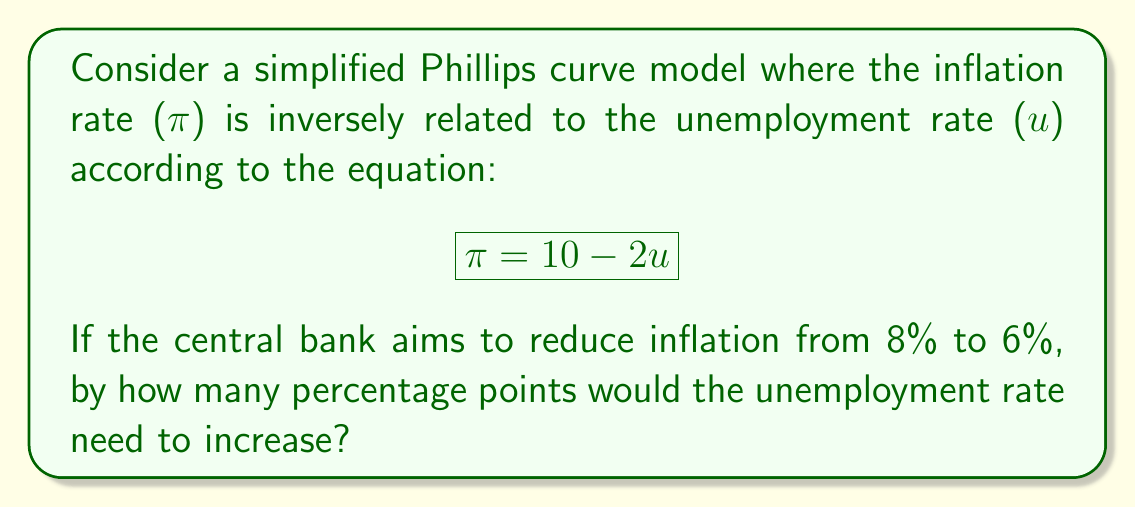What is the answer to this math problem? Let's approach this step-by-step:

1) We're given the Phillips curve equation: $\pi = 10 - 2u$

2) We need to find the change in unemployment ($\Delta u$) that corresponds to a change in inflation from 8% to 6% ($\Delta \pi = -2$)

3) Let's denote the initial and final states:
   Initial: $\pi_1 = 8$, $u_1$ (unknown)
   Final: $\pi_2 = 6$, $u_2$ (unknown)

4) We can set up two equations:
   $8 = 10 - 2u_1$
   $6 = 10 - 2u_2$

5) Solving for $u_1$ and $u_2$:
   $u_1 = (10 - 8) / 2 = 1$
   $u_2 = (10 - 6) / 2 = 2$

6) The change in unemployment is:
   $\Delta u = u_2 - u_1 = 2 - 1 = 1$

Therefore, the unemployment rate would need to increase by 1 percentage point.

This illustrates the trade-off central banks face: lowering inflation often comes at the cost of higher unemployment, at least in the short run according to the Phillips curve model.
Answer: 1 percentage point 